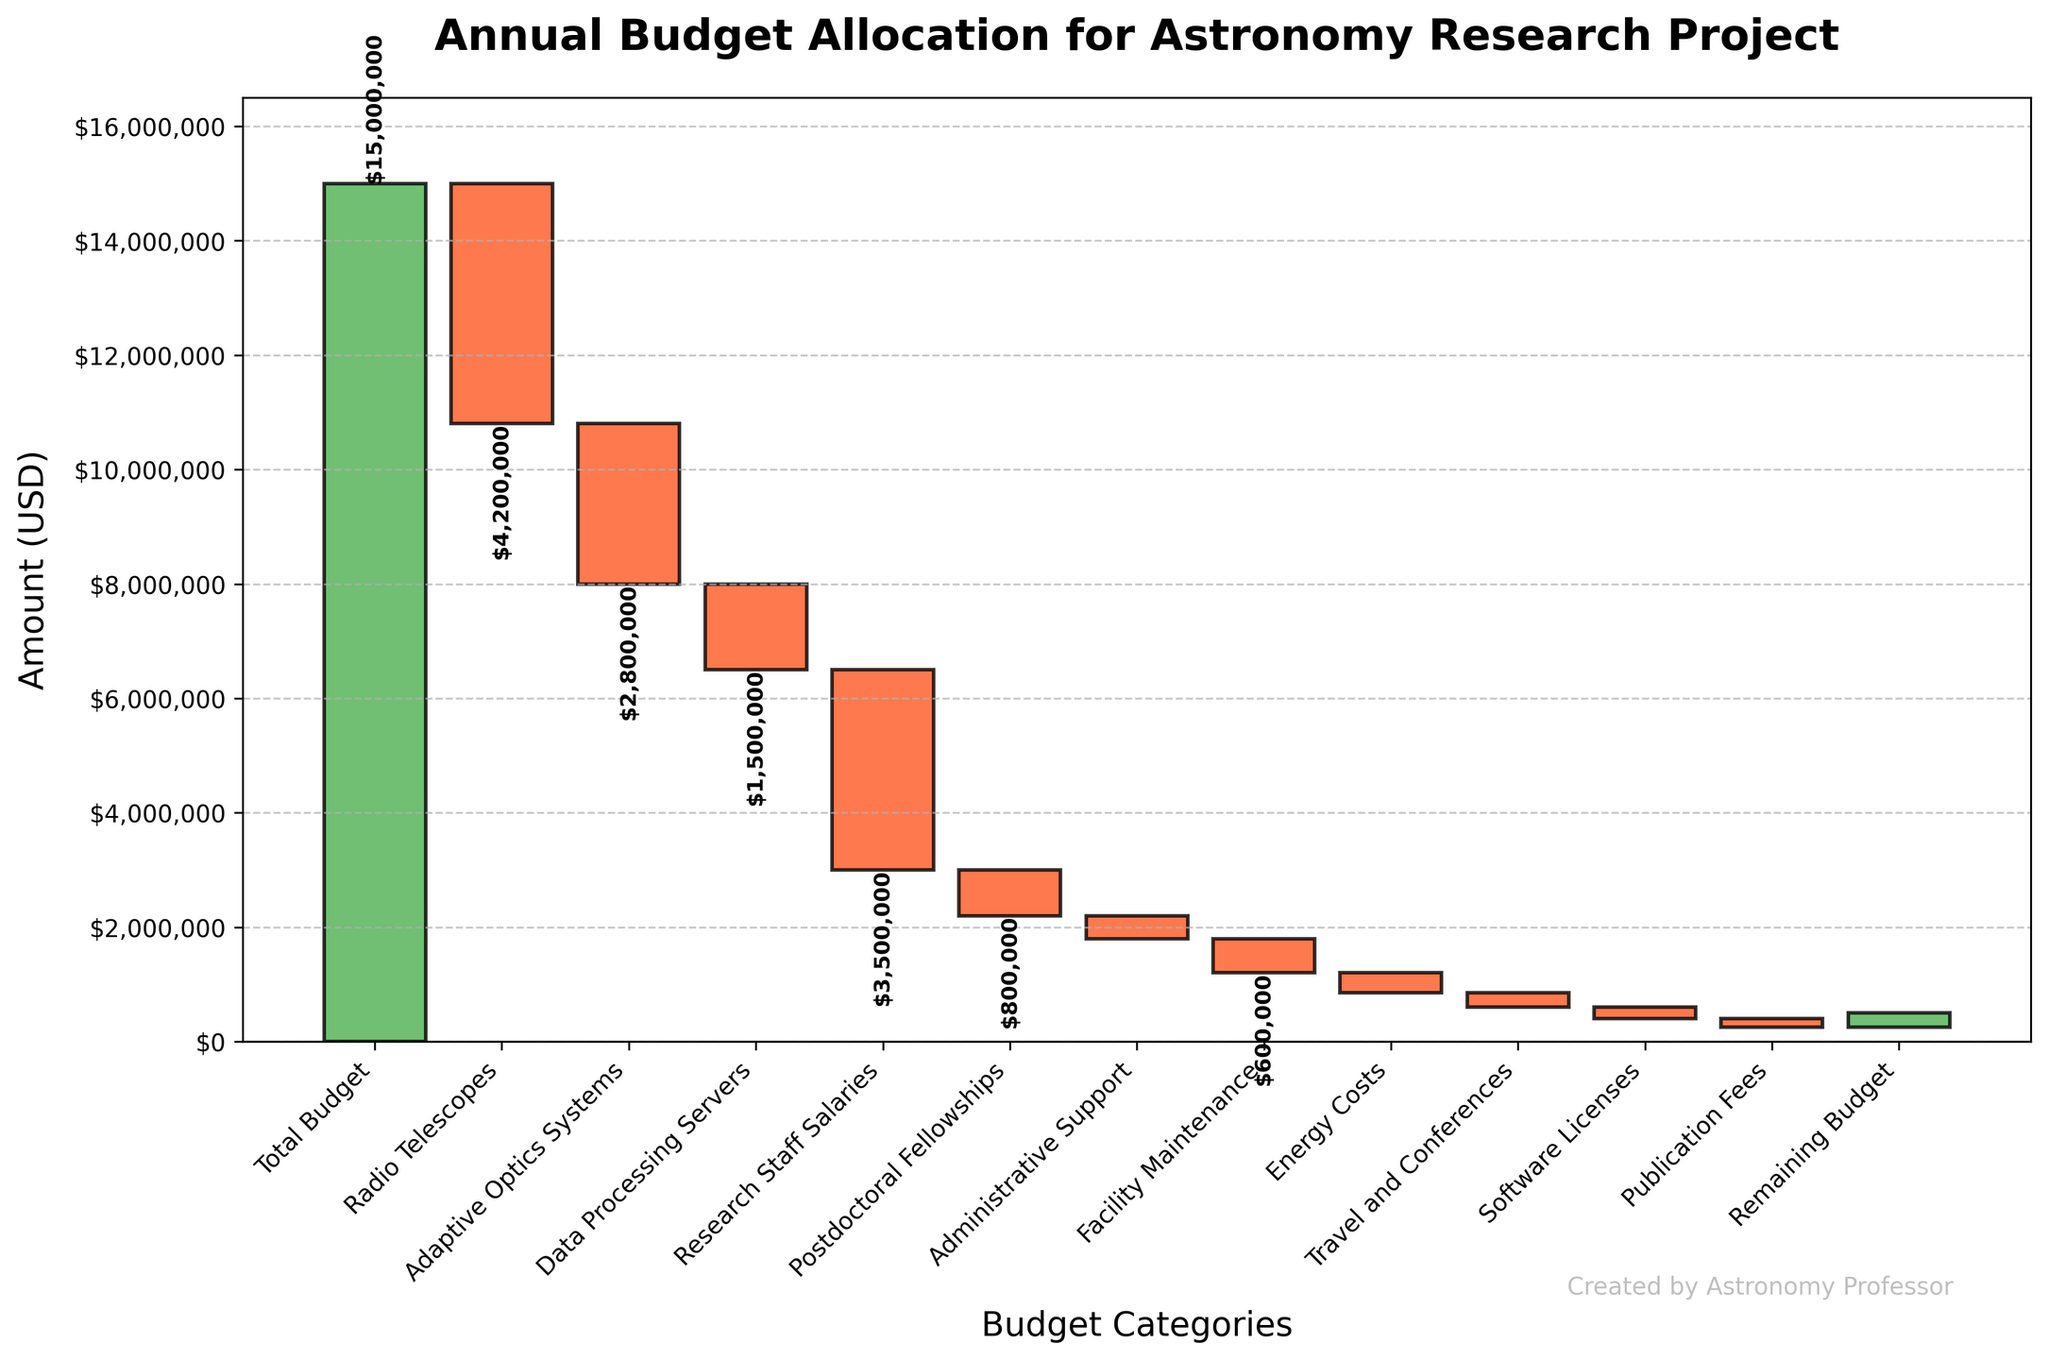What's the total budget for the astronomy research project? The title of the chart indicates it is about annual budget allocation. The first bar represents the 'Total Budget' value.
Answer: $15,000,000 Which budget category has the largest expense? By examining the heights of the bars, the 'Radio Telescopes' category, which has the longest red bar, has the largest expense.
Answer: Radio Telescopes How much money is allocated to 'Facility Maintenance'? Find the 'Facility Maintenance' category and read the label at the top of the respective bar, which shows the value.
Answer: $600,000 What is the cumulative value after accounting for 'Research Staff Salaries'? To find the cumulative value, sum all previous amounts including 'Research Staff Salaries': 15,000,000 (Total Budget) - 4,200,000 (Radio Telescopes) - 2,800,000 (Adaptive Optics Systems) - 1,500,000 (Data Processing Servers) - 3,500,000 (Research Staff Salaries).
Answer: $3,000,000 Which category contributes the least to expenses? The bar with the smallest value (length) is 'Publication Fees'.
Answer: Publication Fees How do the expenses for 'Energy Costs' and 'Travel and Conferences' compare? By comparing the heights of the bars for 'Energy Costs' ($350,000) and 'Travel and Conferences' ($250,000), 'Energy Costs' are higher.
Answer: Energy Costs > Travel and Conferences What is the remaining budget after all expenses? The last bar represents the 'Remaining Budget' which is shown at the end of the cumulative sum.
Answer: $250,000 What is the total expense in staff-related costs (Research Staff Salaries and Postdoctoral Fellowships)? Sum the values of 'Research Staff Salaries' and 'Postdoctoral Fellowships': $3,500,000 + $800,000.
Answer: $4,300,000 How does the expense on 'Adaptive Optics Systems' compare to 'Data Processing Servers'? Compare the values on the bars: 'Adaptive Optics Systems' is $2,800,000, and 'Data Processing Servers' is $1,500,000. Adaptive Optics Systems have higher expenses.
Answer: Adaptive Optics Systems > Data Processing Servers 